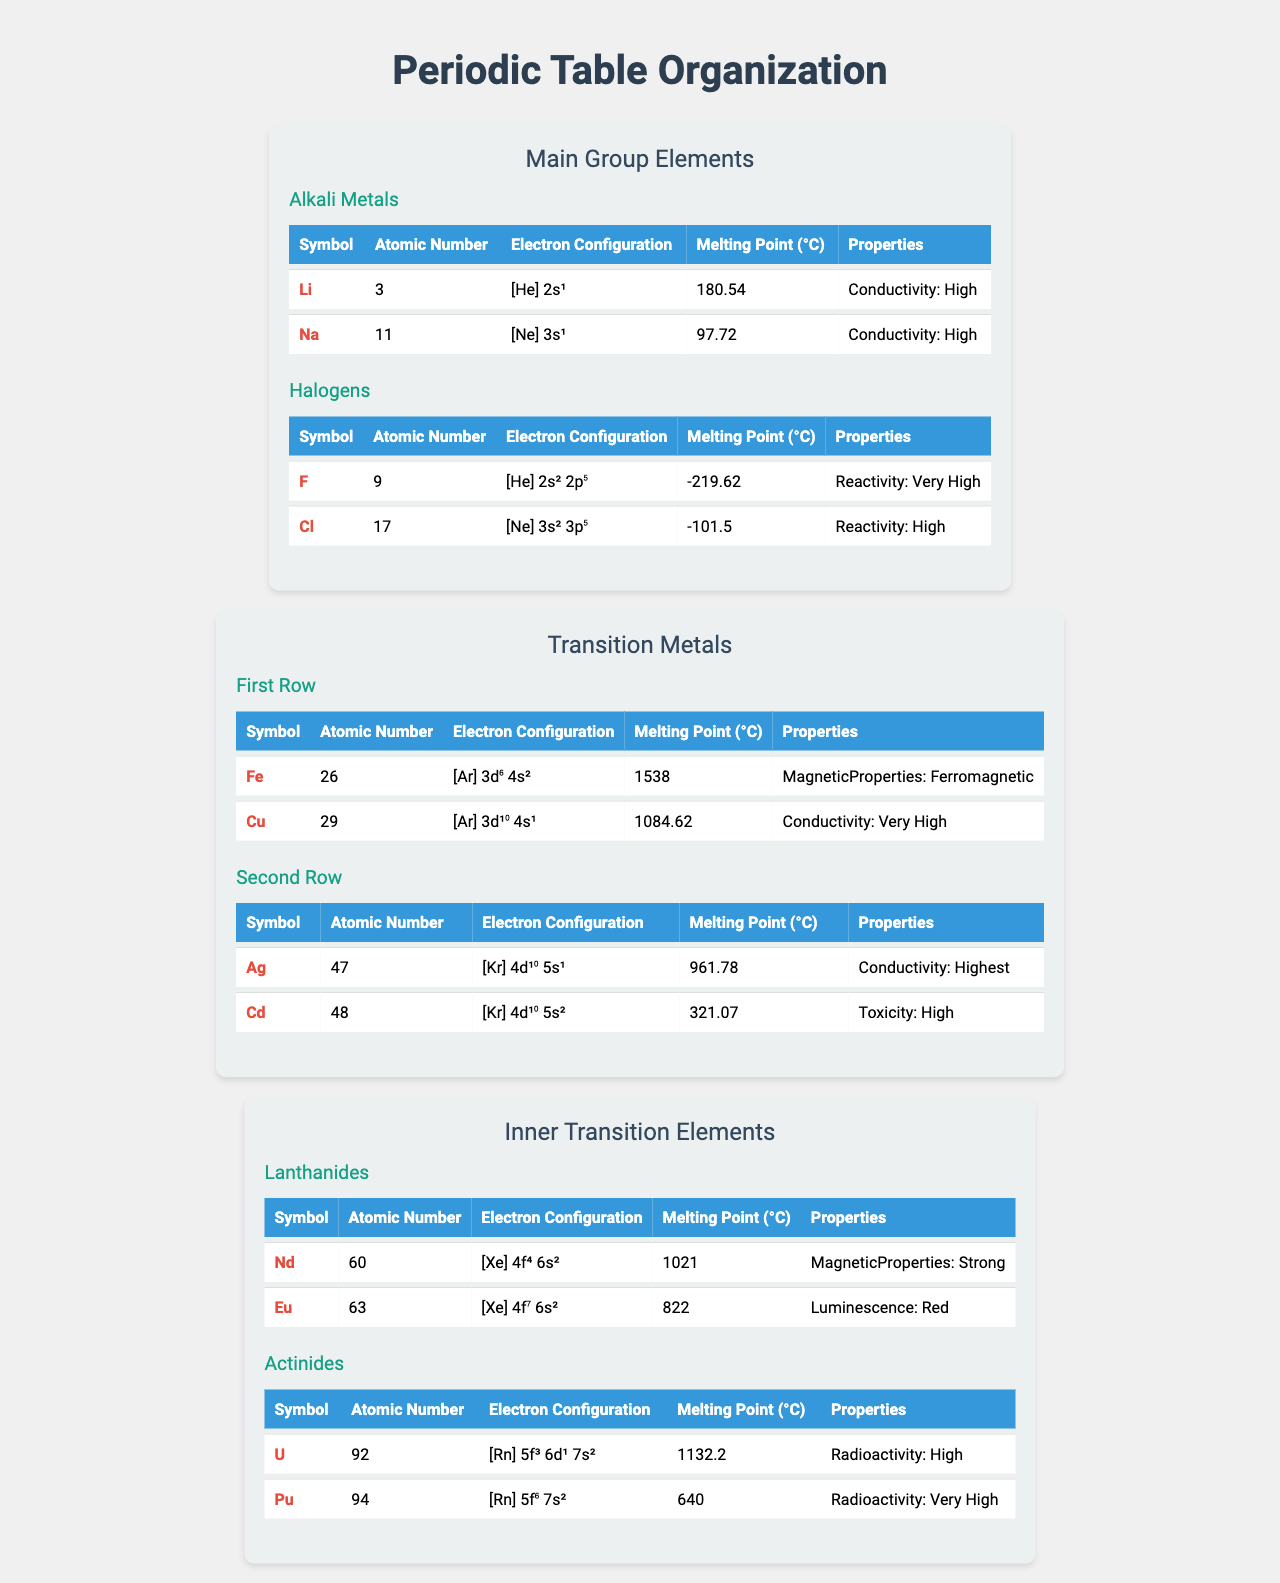What is the melting point of Lithium? The melting point for Lithium is listed in the table under its properties, specifically mentioned as 180.54 °C.
Answer: 180.54 °C Which element has the highest melting point in the Transition Metals group? In the Transition Metals section of the table, Iron has the highest melting point of 1538 °C compared to Copper, which melts at 1084.62 °C.
Answer: 1538 °C Does Chlorine have a higher melting point than Fluorine? The table shows that Chlorine's melting point is -101.5 °C while Fluorine's is -219.62 °C, indicating that Chlorine has a higher melting point than Fluorine.
Answer: Yes Which subgroup contains Silver? Silver is found in the "Second Row" subgroup under the "Transition Metals" group in the table.
Answer: Second Row What is the average melting point of the Inner Transition Elements (Lanthanides and Actinides)? The melting points for Nd and Eu in Lanthanides are 1021 °C and 822 °C respectively, and U and Pu in Actinides are 1132.2 °C and 640 °C, respectively. The average is calculated as (1021 + 822 + 1132.2 + 640) / 4 = 828.55 °C.
Answer: 828.55 °C Which element has both Ferromagnetic properties and a melting point above 1500 °C? The table shows that Iron (Fe) is the only element listed with Ferromagnetic properties and a melting point of 1538 °C, above 1500 °C.
Answer: Iron How many elements are listed under the Alkali Metals subgroup? The table lists two elements under the Alkali Metals subgroup: Lithium (Li) and Sodium (Na).
Answer: 2 Is the radioactivity of Uranium higher than that of Plutonium? The table shows Uranium has "High" radioactivity while Plutonium is marked "Very High," indicating that Plutonium is indeed more radioactive.
Answer: No What is the difference in melting points between Copper and Cadmium? According to the table, Copper melts at 1084.62 °C and Cadmium at 321.07 °C. The difference is calculated as 1084.62 - 321.07 = 763.55 °C.
Answer: 763.55 °C Which element in the table exhibits luminescence and what is its melting point? The table indicates that Europium (Eu) exhibits red luminescence and has a melting point of 822 °C.
Answer: Europium, 822 °C 